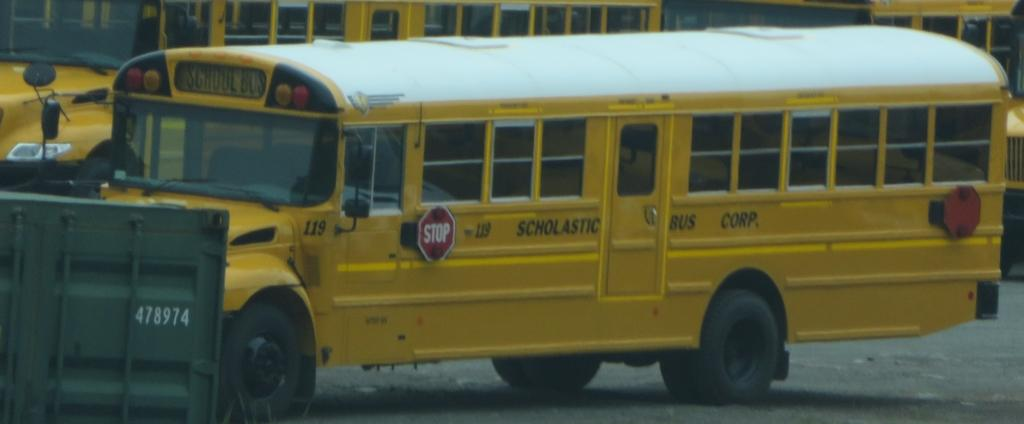Provide a one-sentence caption for the provided image. A Scholastic Bus Corporation school bus is parked in a lot. 